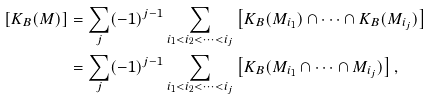<formula> <loc_0><loc_0><loc_500><loc_500>\left [ K _ { B } ( M ) \right ] & = \sum _ { j } ( - 1 ) ^ { j - 1 } \sum _ { i _ { 1 } < i _ { 2 } < \cdots < i _ { j } } \left [ K _ { B } ( M _ { i _ { 1 } } ) \cap \cdots \cap K _ { B } ( M _ { i _ { j } } ) \right ] \\ & = \sum _ { j } ( - 1 ) ^ { j - 1 } \sum _ { i _ { 1 } < i _ { 2 } < \cdots < i _ { j } } \left [ K _ { B } ( M _ { i _ { 1 } } \cap \cdots \cap M _ { i _ { j } } ) \right ] ,</formula> 